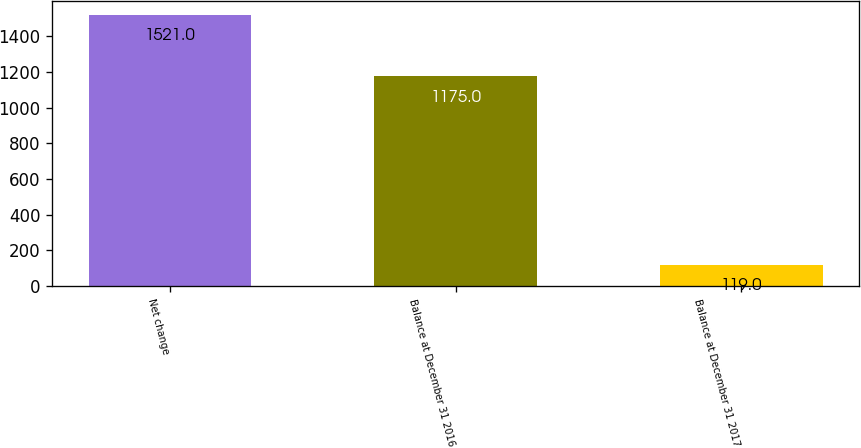<chart> <loc_0><loc_0><loc_500><loc_500><bar_chart><fcel>Net change<fcel>Balance at December 31 2016<fcel>Balance at December 31 2017<nl><fcel>1521<fcel>1175<fcel>119<nl></chart> 